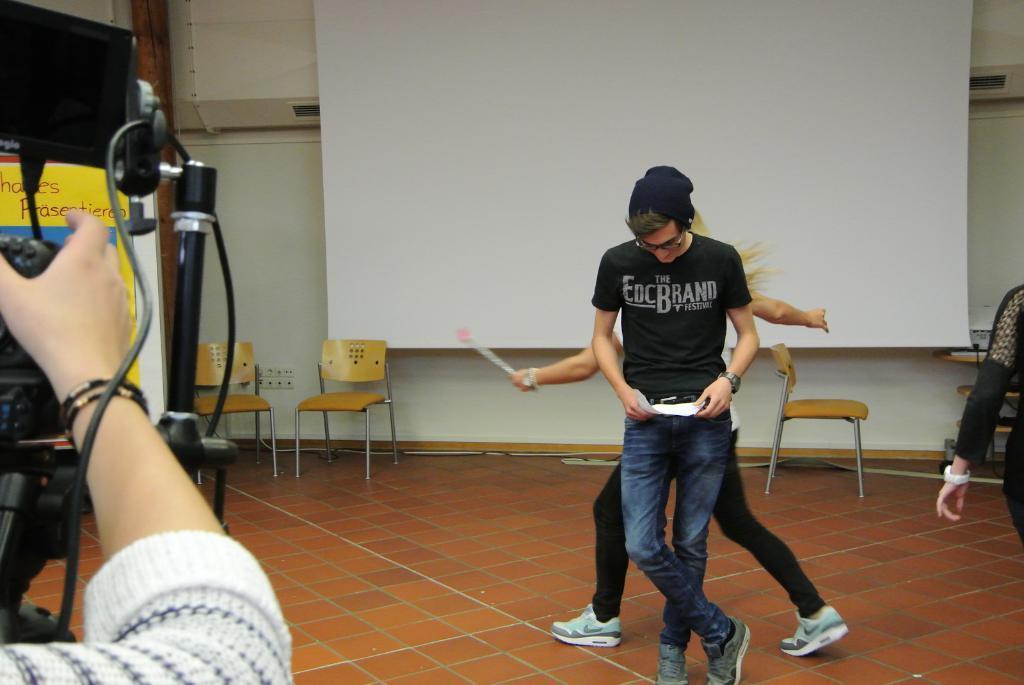How would you summarize this image in a sentence or two? There are two people dancing in the image. At the left corner of the image there is person shooting a video. In front of him there is a camera. In the background there is a board, wall and chairs. 